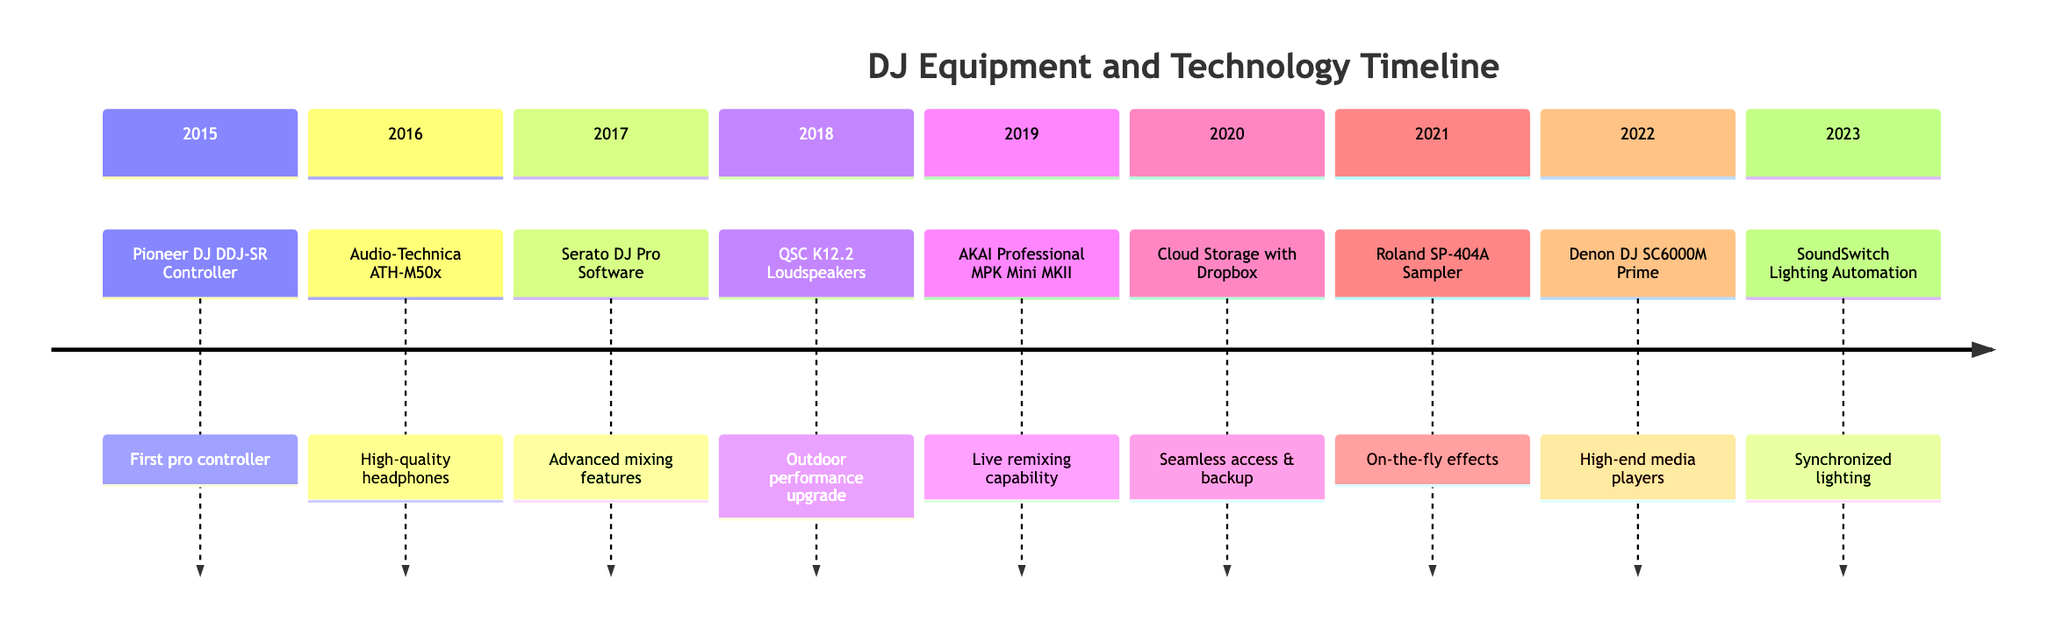What was the first major acquisition in the timeline? The timeline starts with the year 2015, where the first major acquisition listed is the Pioneer DJ DDJ-SR controller. This can be confirmed by checking the first entry in the timeline for the year 2015.
Answer: Pioneer DJ DDJ-SR Controller Which equipment was acquired in 2019? According to the timeline, the acquisition in 2019 is the AKAI Professional MPK Mini MKII, as identified in that year's entry when reviewing the events chronologically.
Answer: AKAI Professional MPK Mini MKII What enhancement was implemented in 2022? The entry for the year 2022 indicates that the enhancement was the Denon DJ SC6000M Prime Media Player, which is classified as an acquisition but refers to it as an enhancement based on its advanced features.
Answer: Denon DJ SC6000M Prime Media Player Which piece of equipment was introduced to facilitate live remixing? Referring to the timeline, the AKAI Professional MPK Mini MKII acquired in 2019 was specifically integrated to include live remixing capabilities during performances. This detail is highlighted in that entry's description.
Answer: AKAI Professional MPK Mini MKII How many equipment acquisitions are listed on the timeline? Counting the entries that specify acquisitions, we see a total of six highlighted acquisitions in the years 2015, 2016, 2018, 2019, 2021, and 2022, while some entries mention enhancements separately.
Answer: 6 What major software enhancement was made in 2017? In the year 2017, the timeline specifies that the Serato DJ Pro software license was acquired, which is categorized as a significant software enhancement in the professional DJ setup.
Answer: Serato DJ Pro Software License Which year saw the introduction of lighting automation? The entry for 2023 in the timeline mentions the incorporation of SoundSwitch Lighting Automation, which indicates that this enhancement was introduced in that year.
Answer: 2023 What type of headphones were acquired in 2016? The data for 2016 indicates the acquisition was for Audio-Technica ATH-M50x headphones, specifically noted for their high-quality sound monitoring capabilities.
Answer: Audio-Technica ATH-M50x Headphones Which equipment was specifically described as improving outdoor performance? In the year 2018, the QSC K12.2 Loudspeakers are noted for their durability and high output, making them ideal for outdoor beach and summer festivals, as clearly stated in the description for that entry.
Answer: QSC K12.2 Loudspeakers 